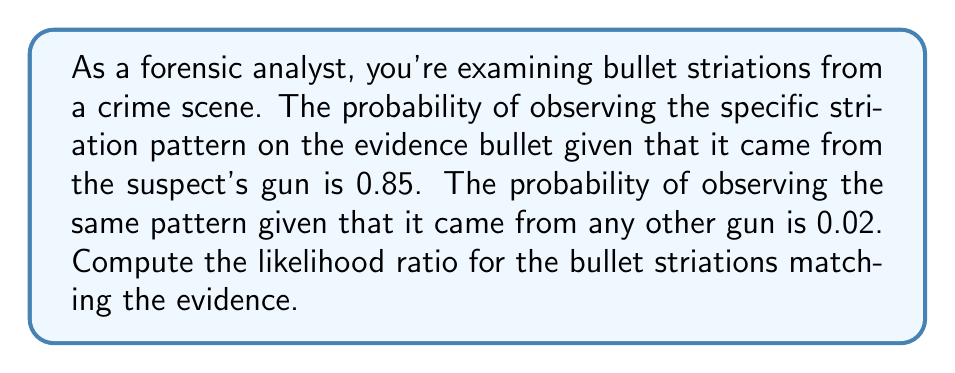Help me with this question. To solve this problem, we need to understand the concept of the likelihood ratio and how to calculate it using the given probabilities.

Step 1: Identify the components of the likelihood ratio
The likelihood ratio (LR) is calculated as:

$$ LR = \frac{P(E|H_1)}{P(E|H_2)} $$

Where:
$P(E|H_1)$ is the probability of the evidence given the first hypothesis (suspect's gun)
$P(E|H_2)$ is the probability of the evidence given the alternative hypothesis (any other gun)

Step 2: Assign the given probabilities
$P(E|H_1) = 0.85$ (probability of observing the pattern given it's from the suspect's gun)
$P(E|H_2) = 0.02$ (probability of observing the pattern given it's from any other gun)

Step 3: Calculate the likelihood ratio
$$ LR = \frac{0.85}{0.02} = 42.5 $$

Step 4: Interpret the result
A likelihood ratio of 42.5 means that the observed striation pattern is 42.5 times more likely to occur if the bullet came from the suspect's gun than if it came from any other gun.
Answer: 42.5 